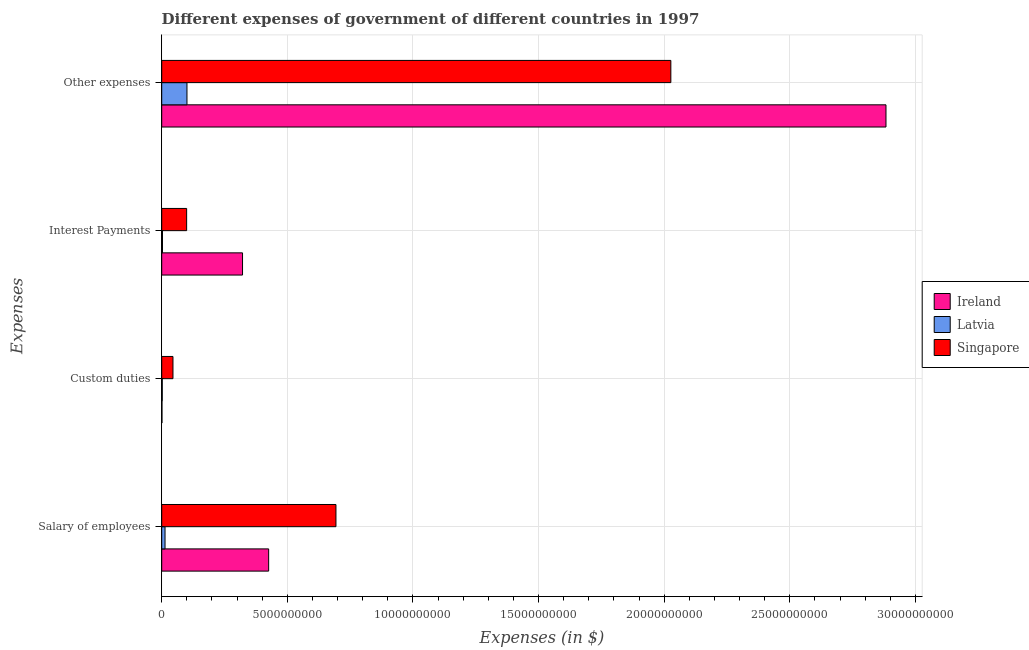How many different coloured bars are there?
Your answer should be compact. 3. Are the number of bars on each tick of the Y-axis equal?
Provide a succinct answer. Yes. How many bars are there on the 3rd tick from the top?
Make the answer very short. 3. What is the label of the 3rd group of bars from the top?
Provide a short and direct response. Custom duties. What is the amount spent on custom duties in Latvia?
Give a very brief answer. 2.20e+07. Across all countries, what is the maximum amount spent on custom duties?
Provide a short and direct response. 4.48e+08. Across all countries, what is the minimum amount spent on interest payments?
Make the answer very short. 3.11e+07. In which country was the amount spent on interest payments maximum?
Your answer should be very brief. Ireland. In which country was the amount spent on salary of employees minimum?
Make the answer very short. Latvia. What is the total amount spent on interest payments in the graph?
Your answer should be very brief. 4.24e+09. What is the difference between the amount spent on custom duties in Ireland and that in Latvia?
Keep it short and to the point. -1.18e+07. What is the difference between the amount spent on other expenses in Latvia and the amount spent on custom duties in Singapore?
Offer a terse response. 5.57e+08. What is the average amount spent on custom duties per country?
Your response must be concise. 1.60e+08. What is the difference between the amount spent on custom duties and amount spent on interest payments in Singapore?
Your response must be concise. -5.44e+08. In how many countries, is the amount spent on interest payments greater than 18000000000 $?
Your answer should be compact. 0. What is the ratio of the amount spent on interest payments in Ireland to that in Latvia?
Your response must be concise. 103.37. Is the difference between the amount spent on other expenses in Singapore and Ireland greater than the difference between the amount spent on custom duties in Singapore and Ireland?
Make the answer very short. No. What is the difference between the highest and the second highest amount spent on interest payments?
Your answer should be very brief. 2.23e+09. What is the difference between the highest and the lowest amount spent on interest payments?
Offer a terse response. 3.19e+09. Is the sum of the amount spent on other expenses in Ireland and Singapore greater than the maximum amount spent on interest payments across all countries?
Make the answer very short. Yes. Is it the case that in every country, the sum of the amount spent on interest payments and amount spent on custom duties is greater than the sum of amount spent on salary of employees and amount spent on other expenses?
Give a very brief answer. No. What does the 1st bar from the top in Other expenses represents?
Offer a terse response. Singapore. What does the 2nd bar from the bottom in Interest Payments represents?
Offer a terse response. Latvia. How many bars are there?
Keep it short and to the point. 12. Are all the bars in the graph horizontal?
Keep it short and to the point. Yes. How many countries are there in the graph?
Offer a terse response. 3. Where does the legend appear in the graph?
Offer a terse response. Center right. How many legend labels are there?
Ensure brevity in your answer.  3. What is the title of the graph?
Your answer should be very brief. Different expenses of government of different countries in 1997. What is the label or title of the X-axis?
Provide a short and direct response. Expenses (in $). What is the label or title of the Y-axis?
Your answer should be very brief. Expenses. What is the Expenses (in $) of Ireland in Salary of employees?
Keep it short and to the point. 4.26e+09. What is the Expenses (in $) of Latvia in Salary of employees?
Ensure brevity in your answer.  1.32e+08. What is the Expenses (in $) in Singapore in Salary of employees?
Your answer should be compact. 6.94e+09. What is the Expenses (in $) of Ireland in Custom duties?
Provide a succinct answer. 1.02e+07. What is the Expenses (in $) in Latvia in Custom duties?
Keep it short and to the point. 2.20e+07. What is the Expenses (in $) of Singapore in Custom duties?
Provide a short and direct response. 4.48e+08. What is the Expenses (in $) in Ireland in Interest Payments?
Provide a short and direct response. 3.22e+09. What is the Expenses (in $) in Latvia in Interest Payments?
Provide a succinct answer. 3.11e+07. What is the Expenses (in $) of Singapore in Interest Payments?
Offer a terse response. 9.92e+08. What is the Expenses (in $) in Ireland in Other expenses?
Provide a short and direct response. 2.88e+1. What is the Expenses (in $) in Latvia in Other expenses?
Your response must be concise. 1.01e+09. What is the Expenses (in $) in Singapore in Other expenses?
Your answer should be very brief. 2.03e+1. Across all Expenses, what is the maximum Expenses (in $) in Ireland?
Ensure brevity in your answer.  2.88e+1. Across all Expenses, what is the maximum Expenses (in $) in Latvia?
Give a very brief answer. 1.01e+09. Across all Expenses, what is the maximum Expenses (in $) in Singapore?
Ensure brevity in your answer.  2.03e+1. Across all Expenses, what is the minimum Expenses (in $) in Ireland?
Offer a very short reply. 1.02e+07. Across all Expenses, what is the minimum Expenses (in $) of Latvia?
Your answer should be very brief. 2.20e+07. Across all Expenses, what is the minimum Expenses (in $) in Singapore?
Offer a terse response. 4.48e+08. What is the total Expenses (in $) of Ireland in the graph?
Make the answer very short. 3.63e+1. What is the total Expenses (in $) in Latvia in the graph?
Keep it short and to the point. 1.19e+09. What is the total Expenses (in $) in Singapore in the graph?
Make the answer very short. 2.86e+1. What is the difference between the Expenses (in $) in Ireland in Salary of employees and that in Custom duties?
Your answer should be very brief. 4.25e+09. What is the difference between the Expenses (in $) of Latvia in Salary of employees and that in Custom duties?
Your answer should be very brief. 1.10e+08. What is the difference between the Expenses (in $) of Singapore in Salary of employees and that in Custom duties?
Make the answer very short. 6.49e+09. What is the difference between the Expenses (in $) in Ireland in Salary of employees and that in Interest Payments?
Offer a very short reply. 1.04e+09. What is the difference between the Expenses (in $) in Latvia in Salary of employees and that in Interest Payments?
Offer a terse response. 1.01e+08. What is the difference between the Expenses (in $) in Singapore in Salary of employees and that in Interest Payments?
Make the answer very short. 5.94e+09. What is the difference between the Expenses (in $) of Ireland in Salary of employees and that in Other expenses?
Provide a short and direct response. -2.46e+1. What is the difference between the Expenses (in $) of Latvia in Salary of employees and that in Other expenses?
Your answer should be compact. -8.73e+08. What is the difference between the Expenses (in $) of Singapore in Salary of employees and that in Other expenses?
Your response must be concise. -1.33e+1. What is the difference between the Expenses (in $) in Ireland in Custom duties and that in Interest Payments?
Give a very brief answer. -3.21e+09. What is the difference between the Expenses (in $) in Latvia in Custom duties and that in Interest Payments?
Keep it short and to the point. -9.12e+06. What is the difference between the Expenses (in $) of Singapore in Custom duties and that in Interest Payments?
Give a very brief answer. -5.44e+08. What is the difference between the Expenses (in $) of Ireland in Custom duties and that in Other expenses?
Ensure brevity in your answer.  -2.88e+1. What is the difference between the Expenses (in $) of Latvia in Custom duties and that in Other expenses?
Give a very brief answer. -9.83e+08. What is the difference between the Expenses (in $) in Singapore in Custom duties and that in Other expenses?
Provide a succinct answer. -1.98e+1. What is the difference between the Expenses (in $) in Ireland in Interest Payments and that in Other expenses?
Your answer should be very brief. -2.56e+1. What is the difference between the Expenses (in $) in Latvia in Interest Payments and that in Other expenses?
Give a very brief answer. -9.74e+08. What is the difference between the Expenses (in $) in Singapore in Interest Payments and that in Other expenses?
Make the answer very short. -1.93e+1. What is the difference between the Expenses (in $) of Ireland in Salary of employees and the Expenses (in $) of Latvia in Custom duties?
Keep it short and to the point. 4.23e+09. What is the difference between the Expenses (in $) of Ireland in Salary of employees and the Expenses (in $) of Singapore in Custom duties?
Keep it short and to the point. 3.81e+09. What is the difference between the Expenses (in $) in Latvia in Salary of employees and the Expenses (in $) in Singapore in Custom duties?
Your response must be concise. -3.16e+08. What is the difference between the Expenses (in $) of Ireland in Salary of employees and the Expenses (in $) of Latvia in Interest Payments?
Keep it short and to the point. 4.23e+09. What is the difference between the Expenses (in $) of Ireland in Salary of employees and the Expenses (in $) of Singapore in Interest Payments?
Make the answer very short. 3.26e+09. What is the difference between the Expenses (in $) of Latvia in Salary of employees and the Expenses (in $) of Singapore in Interest Payments?
Your answer should be compact. -8.60e+08. What is the difference between the Expenses (in $) in Ireland in Salary of employees and the Expenses (in $) in Latvia in Other expenses?
Your answer should be compact. 3.25e+09. What is the difference between the Expenses (in $) in Ireland in Salary of employees and the Expenses (in $) in Singapore in Other expenses?
Offer a terse response. -1.60e+1. What is the difference between the Expenses (in $) in Latvia in Salary of employees and the Expenses (in $) in Singapore in Other expenses?
Offer a very short reply. -2.01e+1. What is the difference between the Expenses (in $) of Ireland in Custom duties and the Expenses (in $) of Latvia in Interest Payments?
Provide a short and direct response. -2.09e+07. What is the difference between the Expenses (in $) of Ireland in Custom duties and the Expenses (in $) of Singapore in Interest Payments?
Provide a succinct answer. -9.82e+08. What is the difference between the Expenses (in $) of Latvia in Custom duties and the Expenses (in $) of Singapore in Interest Payments?
Give a very brief answer. -9.70e+08. What is the difference between the Expenses (in $) of Ireland in Custom duties and the Expenses (in $) of Latvia in Other expenses?
Offer a very short reply. -9.95e+08. What is the difference between the Expenses (in $) in Ireland in Custom duties and the Expenses (in $) in Singapore in Other expenses?
Offer a terse response. -2.03e+1. What is the difference between the Expenses (in $) in Latvia in Custom duties and the Expenses (in $) in Singapore in Other expenses?
Offer a terse response. -2.02e+1. What is the difference between the Expenses (in $) of Ireland in Interest Payments and the Expenses (in $) of Latvia in Other expenses?
Provide a short and direct response. 2.21e+09. What is the difference between the Expenses (in $) in Ireland in Interest Payments and the Expenses (in $) in Singapore in Other expenses?
Make the answer very short. -1.70e+1. What is the difference between the Expenses (in $) of Latvia in Interest Payments and the Expenses (in $) of Singapore in Other expenses?
Ensure brevity in your answer.  -2.02e+1. What is the average Expenses (in $) of Ireland per Expenses?
Your answer should be compact. 9.08e+09. What is the average Expenses (in $) in Latvia per Expenses?
Make the answer very short. 2.98e+08. What is the average Expenses (in $) in Singapore per Expenses?
Your response must be concise. 7.16e+09. What is the difference between the Expenses (in $) in Ireland and Expenses (in $) in Latvia in Salary of employees?
Offer a very short reply. 4.12e+09. What is the difference between the Expenses (in $) in Ireland and Expenses (in $) in Singapore in Salary of employees?
Provide a short and direct response. -2.68e+09. What is the difference between the Expenses (in $) of Latvia and Expenses (in $) of Singapore in Salary of employees?
Provide a succinct answer. -6.80e+09. What is the difference between the Expenses (in $) in Ireland and Expenses (in $) in Latvia in Custom duties?
Make the answer very short. -1.18e+07. What is the difference between the Expenses (in $) of Ireland and Expenses (in $) of Singapore in Custom duties?
Keep it short and to the point. -4.38e+08. What is the difference between the Expenses (in $) of Latvia and Expenses (in $) of Singapore in Custom duties?
Ensure brevity in your answer.  -4.26e+08. What is the difference between the Expenses (in $) in Ireland and Expenses (in $) in Latvia in Interest Payments?
Keep it short and to the point. 3.19e+09. What is the difference between the Expenses (in $) in Ireland and Expenses (in $) in Singapore in Interest Payments?
Your answer should be compact. 2.23e+09. What is the difference between the Expenses (in $) in Latvia and Expenses (in $) in Singapore in Interest Payments?
Give a very brief answer. -9.61e+08. What is the difference between the Expenses (in $) in Ireland and Expenses (in $) in Latvia in Other expenses?
Your response must be concise. 2.78e+1. What is the difference between the Expenses (in $) in Ireland and Expenses (in $) in Singapore in Other expenses?
Provide a succinct answer. 8.56e+09. What is the difference between the Expenses (in $) of Latvia and Expenses (in $) of Singapore in Other expenses?
Keep it short and to the point. -1.93e+1. What is the ratio of the Expenses (in $) in Ireland in Salary of employees to that in Custom duties?
Your answer should be very brief. 415.42. What is the ratio of the Expenses (in $) in Latvia in Salary of employees to that in Custom duties?
Provide a short and direct response. 6.02. What is the ratio of the Expenses (in $) of Singapore in Salary of employees to that in Custom duties?
Provide a short and direct response. 15.48. What is the ratio of the Expenses (in $) of Ireland in Salary of employees to that in Interest Payments?
Make the answer very short. 1.32. What is the ratio of the Expenses (in $) in Latvia in Salary of employees to that in Interest Payments?
Your response must be concise. 4.26. What is the ratio of the Expenses (in $) in Singapore in Salary of employees to that in Interest Payments?
Ensure brevity in your answer.  6.99. What is the ratio of the Expenses (in $) of Ireland in Salary of employees to that in Other expenses?
Your response must be concise. 0.15. What is the ratio of the Expenses (in $) in Latvia in Salary of employees to that in Other expenses?
Provide a short and direct response. 0.13. What is the ratio of the Expenses (in $) in Singapore in Salary of employees to that in Other expenses?
Provide a short and direct response. 0.34. What is the ratio of the Expenses (in $) of Ireland in Custom duties to that in Interest Payments?
Provide a short and direct response. 0. What is the ratio of the Expenses (in $) in Latvia in Custom duties to that in Interest Payments?
Provide a succinct answer. 0.71. What is the ratio of the Expenses (in $) in Singapore in Custom duties to that in Interest Payments?
Your response must be concise. 0.45. What is the ratio of the Expenses (in $) in Ireland in Custom duties to that in Other expenses?
Keep it short and to the point. 0. What is the ratio of the Expenses (in $) in Latvia in Custom duties to that in Other expenses?
Keep it short and to the point. 0.02. What is the ratio of the Expenses (in $) of Singapore in Custom duties to that in Other expenses?
Your answer should be very brief. 0.02. What is the ratio of the Expenses (in $) in Ireland in Interest Payments to that in Other expenses?
Your response must be concise. 0.11. What is the ratio of the Expenses (in $) of Latvia in Interest Payments to that in Other expenses?
Offer a very short reply. 0.03. What is the ratio of the Expenses (in $) in Singapore in Interest Payments to that in Other expenses?
Make the answer very short. 0.05. What is the difference between the highest and the second highest Expenses (in $) of Ireland?
Offer a terse response. 2.46e+1. What is the difference between the highest and the second highest Expenses (in $) of Latvia?
Your response must be concise. 8.73e+08. What is the difference between the highest and the second highest Expenses (in $) in Singapore?
Your response must be concise. 1.33e+1. What is the difference between the highest and the lowest Expenses (in $) of Ireland?
Ensure brevity in your answer.  2.88e+1. What is the difference between the highest and the lowest Expenses (in $) of Latvia?
Provide a short and direct response. 9.83e+08. What is the difference between the highest and the lowest Expenses (in $) in Singapore?
Your answer should be compact. 1.98e+1. 